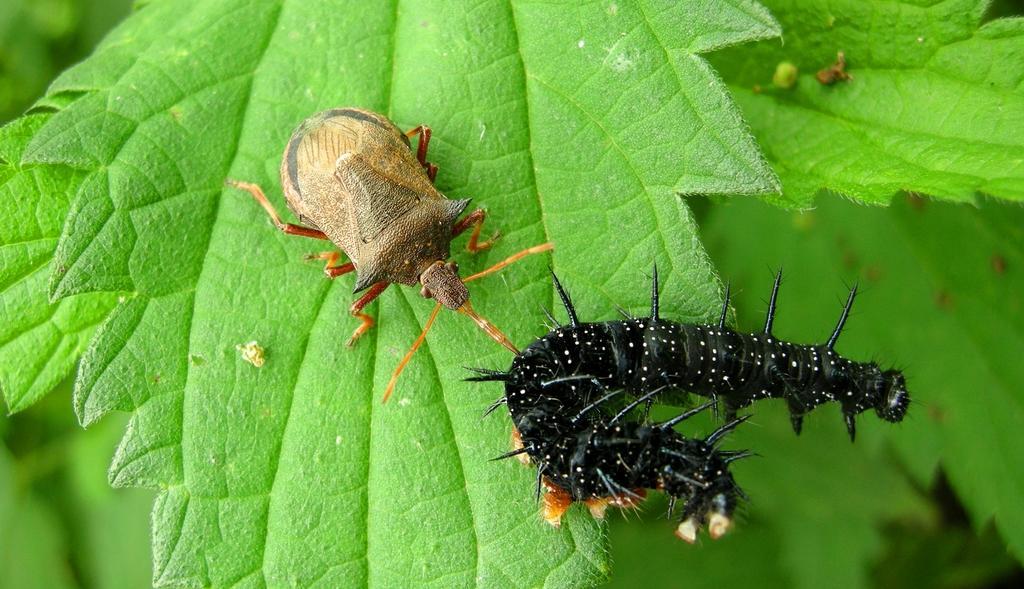Please provide a concise description of this image. In this image, we can see insects on the leaf. In the background, image is blurred. 